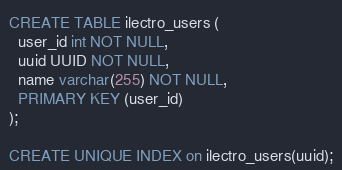Convert code to text. <code><loc_0><loc_0><loc_500><loc_500><_SQL_>CREATE TABLE ilectro_users (
  user_id int NOT NULL,
  uuid UUID NOT NULL,
  name varchar(255) NOT NULL,
  PRIMARY KEY (user_id)
);

CREATE UNIQUE INDEX on ilectro_users(uuid);</code> 